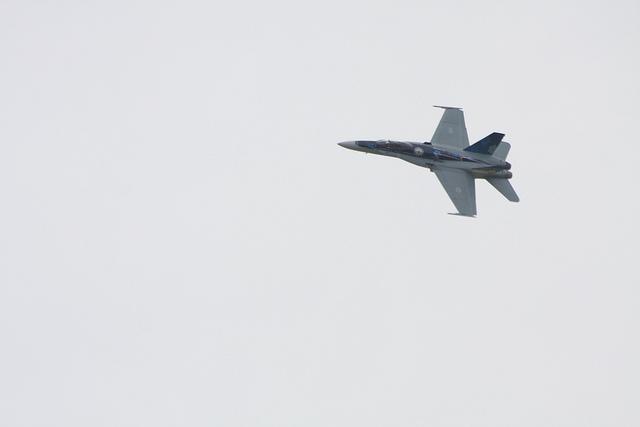How many jets are here?
Give a very brief answer. 1. How many planes are there?
Give a very brief answer. 1. 